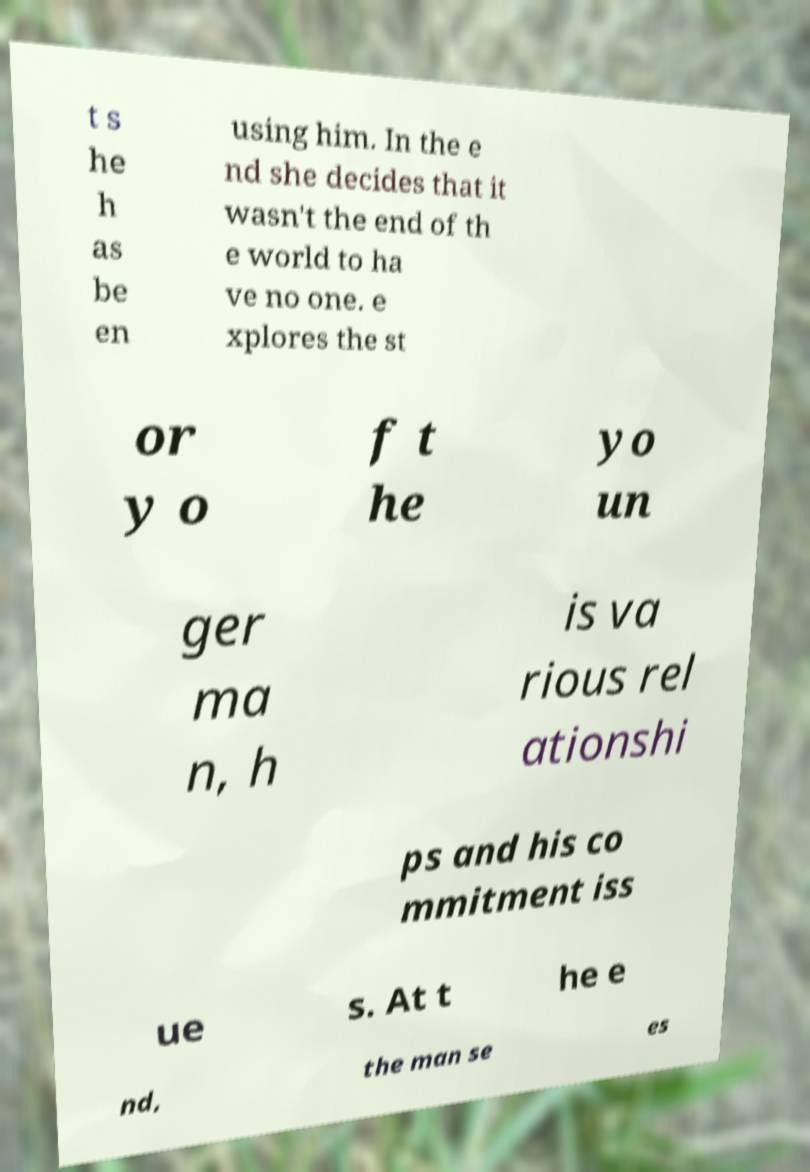Please read and relay the text visible in this image. What does it say? t s he h as be en using him. In the e nd she decides that it wasn't the end of th e world to ha ve no one. e xplores the st or y o f t he yo un ger ma n, h is va rious rel ationshi ps and his co mmitment iss ue s. At t he e nd, the man se es 